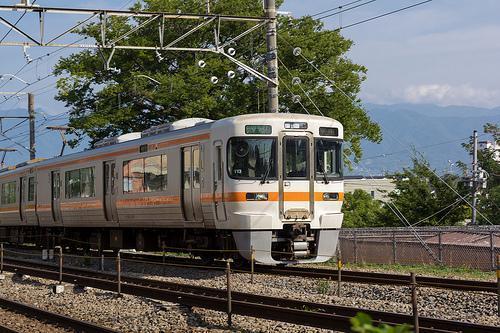How many trains are in the photo?
Give a very brief answer. 1. 